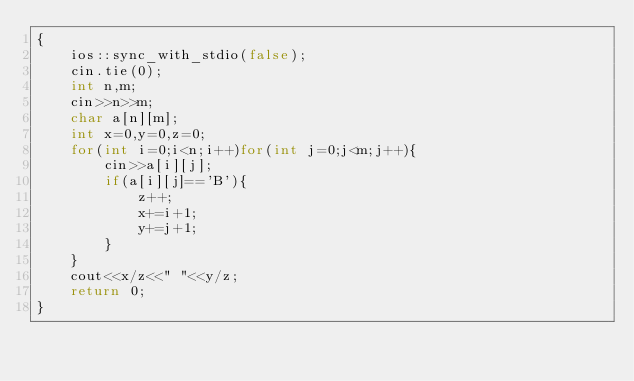Convert code to text. <code><loc_0><loc_0><loc_500><loc_500><_C++_>{
    ios::sync_with_stdio(false);
    cin.tie(0);
    int n,m;
    cin>>n>>m;
    char a[n][m];
    int x=0,y=0,z=0;
    for(int i=0;i<n;i++)for(int j=0;j<m;j++){
        cin>>a[i][j];
        if(a[i][j]=='B'){
            z++;
            x+=i+1;
            y+=j+1;
        }
    }
    cout<<x/z<<" "<<y/z;
    return 0;
}</code> 